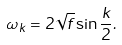Convert formula to latex. <formula><loc_0><loc_0><loc_500><loc_500>\omega _ { k } = 2 \sqrt { f } \sin { \frac { k } { 2 } } .</formula> 